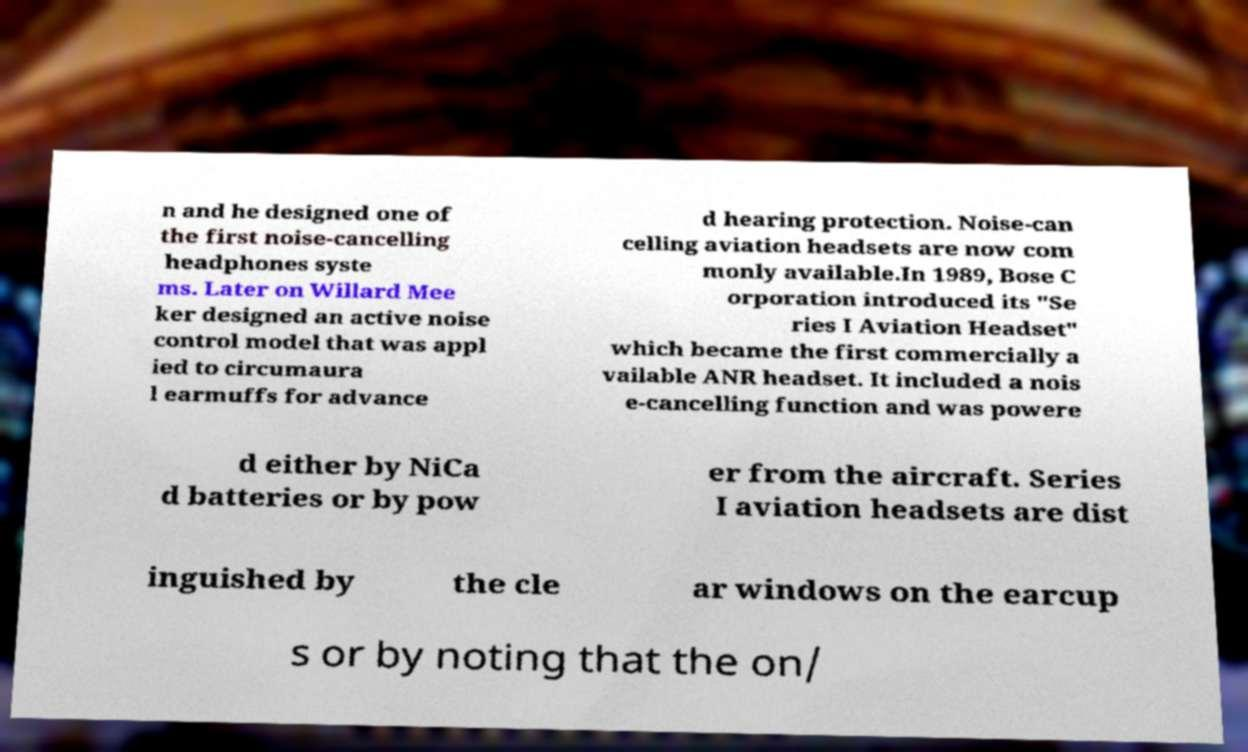For documentation purposes, I need the text within this image transcribed. Could you provide that? n and he designed one of the first noise-cancelling headphones syste ms. Later on Willard Mee ker designed an active noise control model that was appl ied to circumaura l earmuffs for advance d hearing protection. Noise-can celling aviation headsets are now com monly available.In 1989, Bose C orporation introduced its "Se ries I Aviation Headset" which became the first commercially a vailable ANR headset. It included a nois e-cancelling function and was powere d either by NiCa d batteries or by pow er from the aircraft. Series I aviation headsets are dist inguished by the cle ar windows on the earcup s or by noting that the on/ 